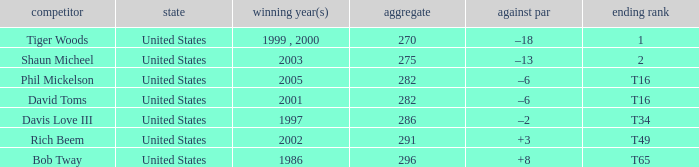In which year(s) did the person with a total greater than 286 win? 2002, 1986. 